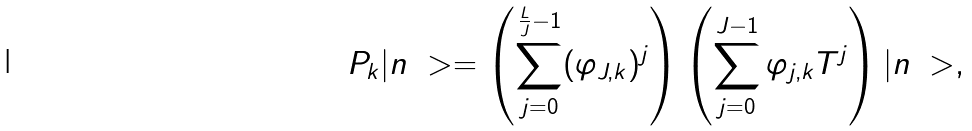Convert formula to latex. <formula><loc_0><loc_0><loc_500><loc_500>P _ { k } | n \ > = \left ( \sum _ { j = 0 } ^ { \frac { L } { J } - 1 } ( \varphi _ { J , k } ) ^ { j } \right ) \left ( \sum _ { j = 0 } ^ { J - 1 } \varphi _ { j , k } T ^ { j } \right ) | n \ > ,</formula> 